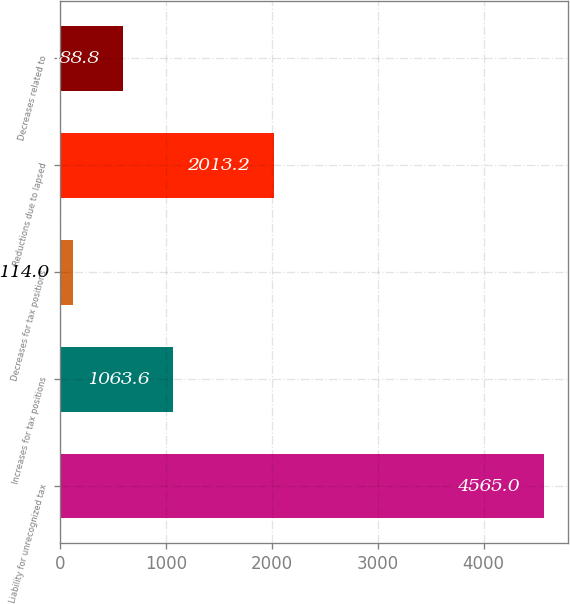Convert chart to OTSL. <chart><loc_0><loc_0><loc_500><loc_500><bar_chart><fcel>Liability for unrecognized tax<fcel>Increases for tax positions<fcel>Decreases for tax positions<fcel>Reductions due to lapsed<fcel>Decreases related to<nl><fcel>4565<fcel>1063.6<fcel>114<fcel>2013.2<fcel>588.8<nl></chart> 